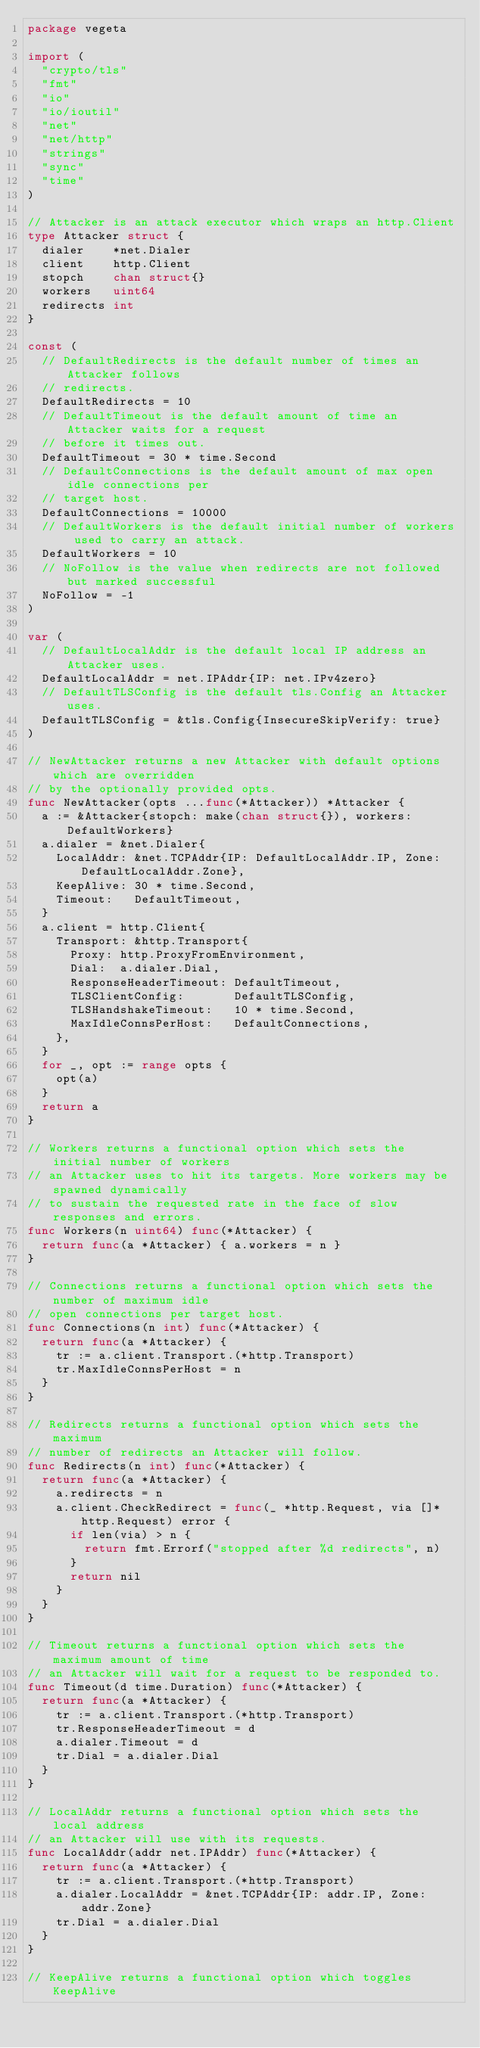Convert code to text. <code><loc_0><loc_0><loc_500><loc_500><_Go_>package vegeta

import (
	"crypto/tls"
	"fmt"
	"io"
	"io/ioutil"
	"net"
	"net/http"
	"strings"
	"sync"
	"time"
)

// Attacker is an attack executor which wraps an http.Client
type Attacker struct {
	dialer    *net.Dialer
	client    http.Client
	stopch    chan struct{}
	workers   uint64
	redirects int
}

const (
	// DefaultRedirects is the default number of times an Attacker follows
	// redirects.
	DefaultRedirects = 10
	// DefaultTimeout is the default amount of time an Attacker waits for a request
	// before it times out.
	DefaultTimeout = 30 * time.Second
	// DefaultConnections is the default amount of max open idle connections per
	// target host.
	DefaultConnections = 10000
	// DefaultWorkers is the default initial number of workers used to carry an attack.
	DefaultWorkers = 10
	// NoFollow is the value when redirects are not followed but marked successful
	NoFollow = -1
)

var (
	// DefaultLocalAddr is the default local IP address an Attacker uses.
	DefaultLocalAddr = net.IPAddr{IP: net.IPv4zero}
	// DefaultTLSConfig is the default tls.Config an Attacker uses.
	DefaultTLSConfig = &tls.Config{InsecureSkipVerify: true}
)

// NewAttacker returns a new Attacker with default options which are overridden
// by the optionally provided opts.
func NewAttacker(opts ...func(*Attacker)) *Attacker {
	a := &Attacker{stopch: make(chan struct{}), workers: DefaultWorkers}
	a.dialer = &net.Dialer{
		LocalAddr: &net.TCPAddr{IP: DefaultLocalAddr.IP, Zone: DefaultLocalAddr.Zone},
		KeepAlive: 30 * time.Second,
		Timeout:   DefaultTimeout,
	}
	a.client = http.Client{
		Transport: &http.Transport{
			Proxy: http.ProxyFromEnvironment,
			Dial:  a.dialer.Dial,
			ResponseHeaderTimeout: DefaultTimeout,
			TLSClientConfig:       DefaultTLSConfig,
			TLSHandshakeTimeout:   10 * time.Second,
			MaxIdleConnsPerHost:   DefaultConnections,
		},
	}
	for _, opt := range opts {
		opt(a)
	}
	return a
}

// Workers returns a functional option which sets the initial number of workers
// an Attacker uses to hit its targets. More workers may be spawned dynamically
// to sustain the requested rate in the face of slow responses and errors.
func Workers(n uint64) func(*Attacker) {
	return func(a *Attacker) { a.workers = n }
}

// Connections returns a functional option which sets the number of maximum idle
// open connections per target host.
func Connections(n int) func(*Attacker) {
	return func(a *Attacker) {
		tr := a.client.Transport.(*http.Transport)
		tr.MaxIdleConnsPerHost = n
	}
}

// Redirects returns a functional option which sets the maximum
// number of redirects an Attacker will follow.
func Redirects(n int) func(*Attacker) {
	return func(a *Attacker) {
		a.redirects = n
		a.client.CheckRedirect = func(_ *http.Request, via []*http.Request) error {
			if len(via) > n {
				return fmt.Errorf("stopped after %d redirects", n)
			}
			return nil
		}
	}
}

// Timeout returns a functional option which sets the maximum amount of time
// an Attacker will wait for a request to be responded to.
func Timeout(d time.Duration) func(*Attacker) {
	return func(a *Attacker) {
		tr := a.client.Transport.(*http.Transport)
		tr.ResponseHeaderTimeout = d
		a.dialer.Timeout = d
		tr.Dial = a.dialer.Dial
	}
}

// LocalAddr returns a functional option which sets the local address
// an Attacker will use with its requests.
func LocalAddr(addr net.IPAddr) func(*Attacker) {
	return func(a *Attacker) {
		tr := a.client.Transport.(*http.Transport)
		a.dialer.LocalAddr = &net.TCPAddr{IP: addr.IP, Zone: addr.Zone}
		tr.Dial = a.dialer.Dial
	}
}

// KeepAlive returns a functional option which toggles KeepAlive</code> 